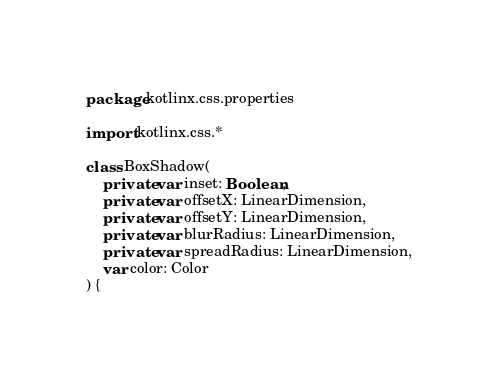<code> <loc_0><loc_0><loc_500><loc_500><_Kotlin_>package kotlinx.css.properties

import kotlinx.css.*

class BoxShadow(
    private var inset: Boolean,
    private var offsetX: LinearDimension,
    private var offsetY: LinearDimension,
    private var blurRadius: LinearDimension,
    private var spreadRadius: LinearDimension,
    var color: Color
) {</code> 